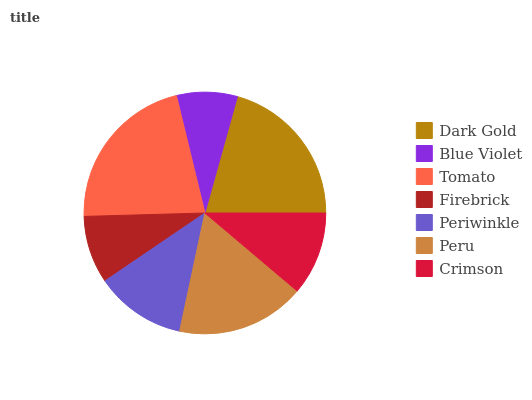Is Blue Violet the minimum?
Answer yes or no. Yes. Is Tomato the maximum?
Answer yes or no. Yes. Is Tomato the minimum?
Answer yes or no. No. Is Blue Violet the maximum?
Answer yes or no. No. Is Tomato greater than Blue Violet?
Answer yes or no. Yes. Is Blue Violet less than Tomato?
Answer yes or no. Yes. Is Blue Violet greater than Tomato?
Answer yes or no. No. Is Tomato less than Blue Violet?
Answer yes or no. No. Is Periwinkle the high median?
Answer yes or no. Yes. Is Periwinkle the low median?
Answer yes or no. Yes. Is Peru the high median?
Answer yes or no. No. Is Crimson the low median?
Answer yes or no. No. 